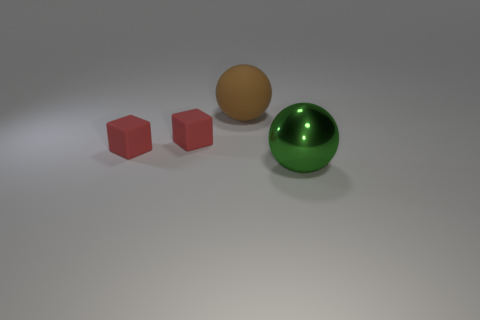Are there more brown rubber objects than cyan rubber objects?
Offer a terse response. Yes. Is there a matte object that is in front of the large object on the left side of the big sphere that is in front of the big matte ball?
Give a very brief answer. Yes. What number of other objects are there of the same size as the brown rubber sphere?
Offer a very short reply. 1. Are there any brown things behind the big rubber ball?
Your response must be concise. No. Is the color of the metal thing the same as the sphere that is on the left side of the green sphere?
Your answer should be compact. No. There is a large thing that is right of the big thing that is behind the large thing that is right of the matte ball; what is its color?
Provide a short and direct response. Green. Is there another big green object that has the same shape as the green object?
Offer a very short reply. No. What color is the thing that is the same size as the brown ball?
Offer a terse response. Green. There is a large sphere on the left side of the big green metal thing; what is it made of?
Your answer should be very brief. Rubber. Do the large thing that is on the right side of the brown matte object and the big thing left of the large green shiny sphere have the same shape?
Your response must be concise. Yes. 